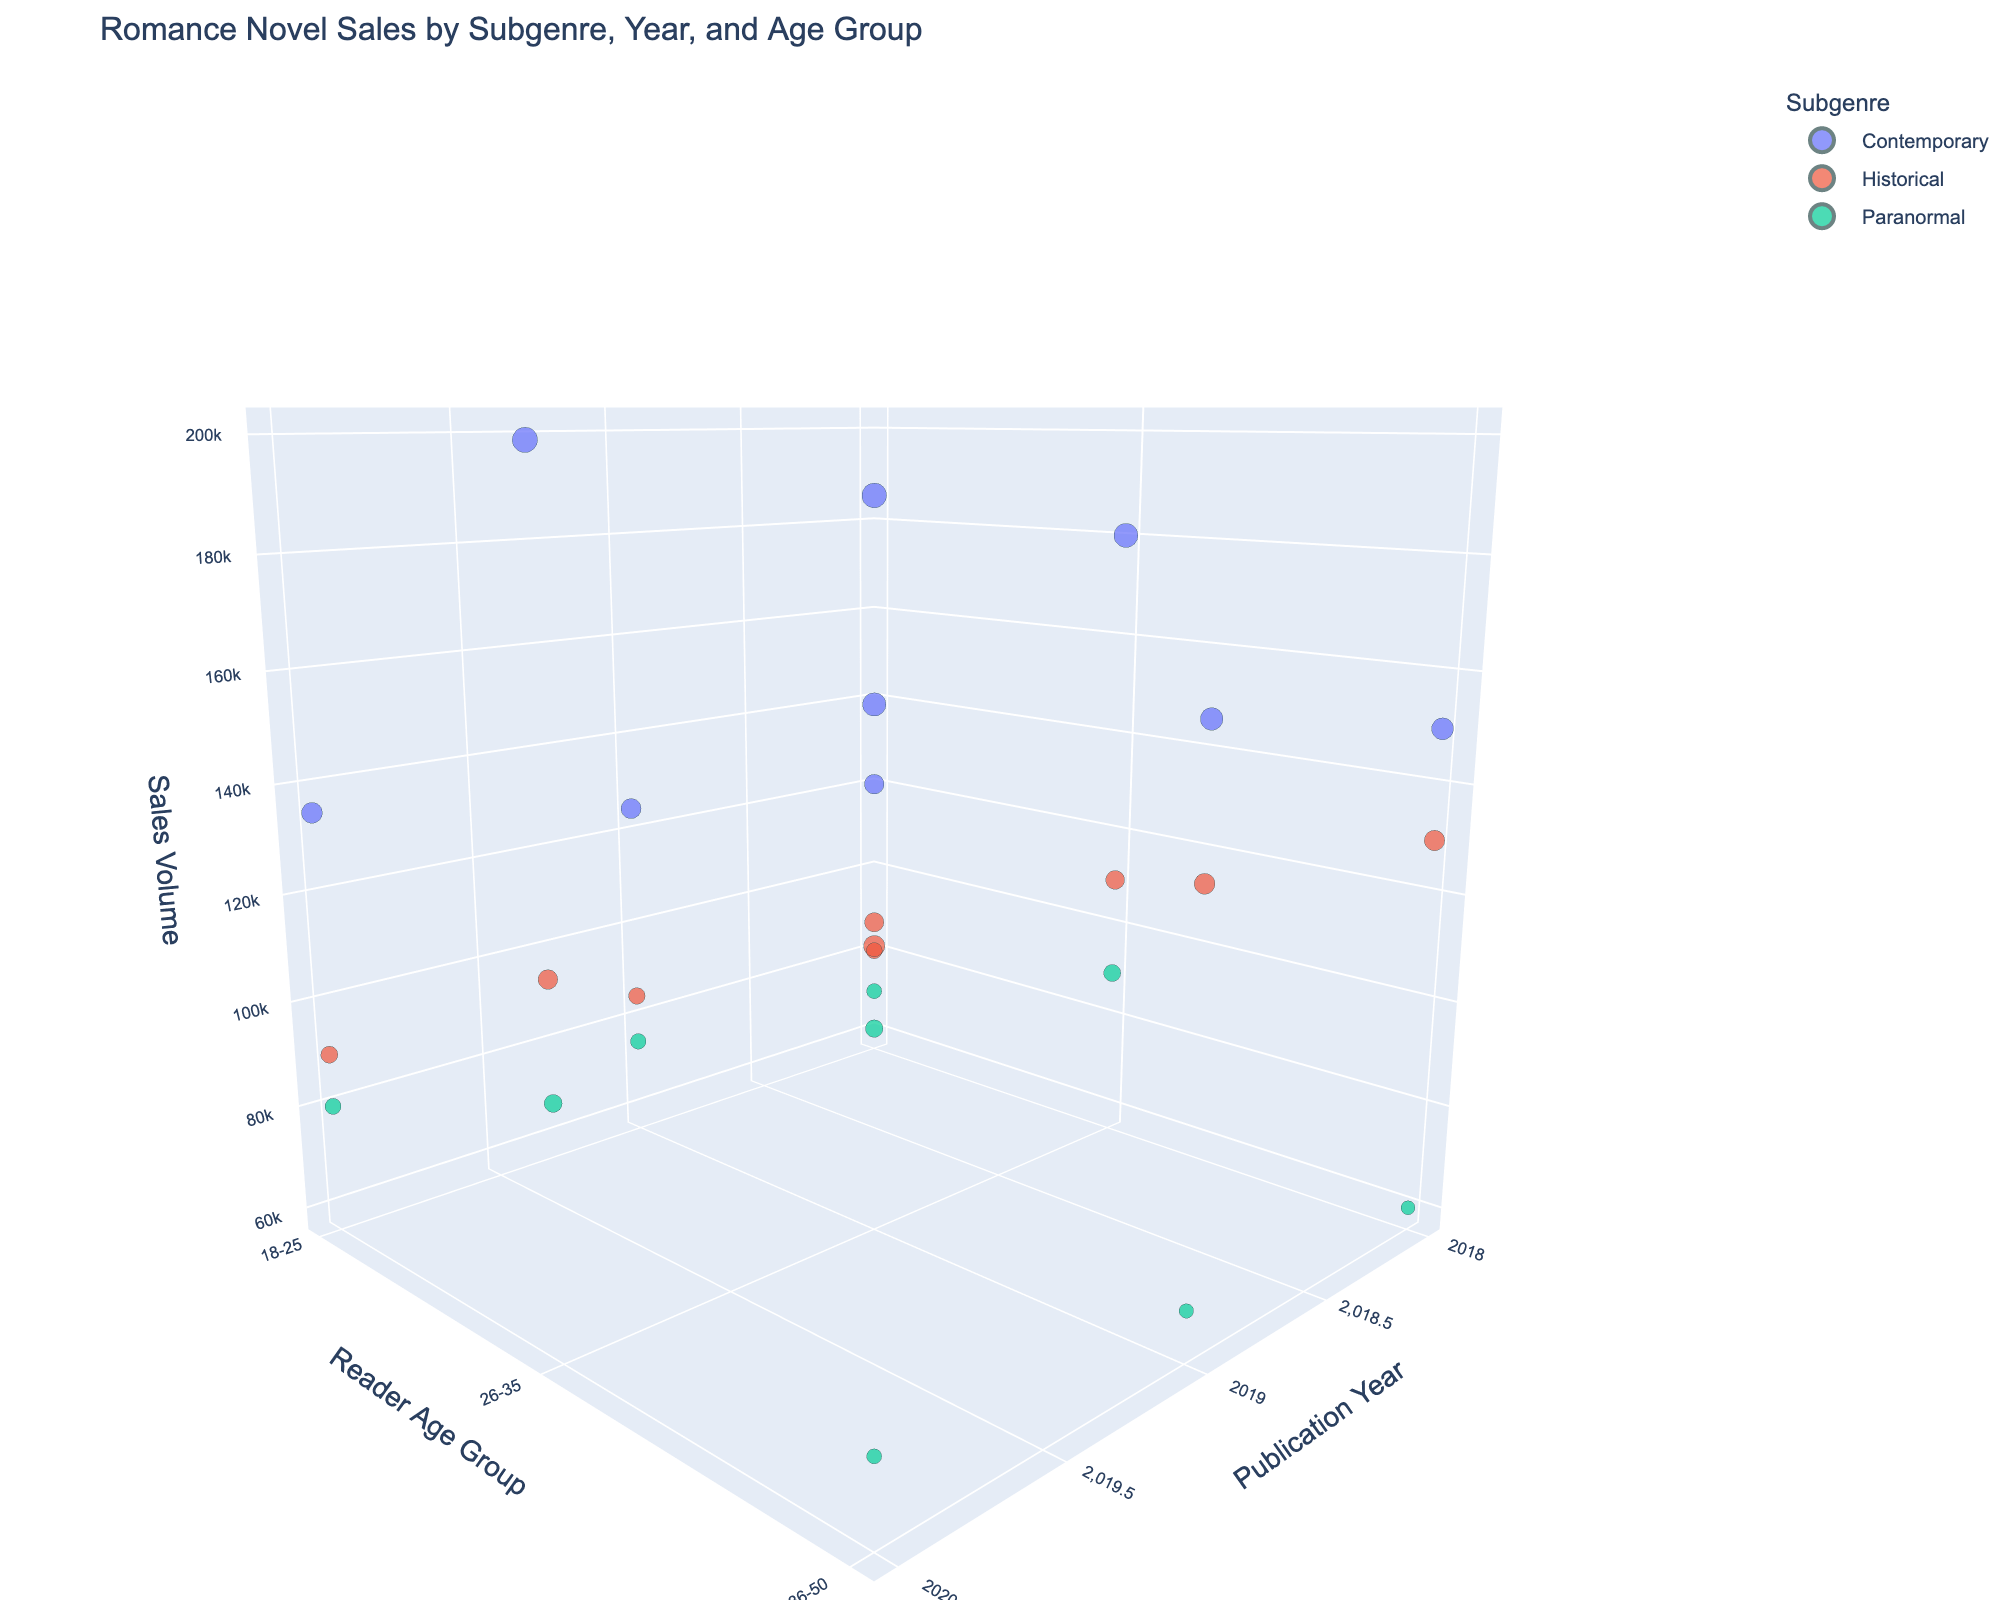What is the title of the figure? The title is often located at the top of the plot and provides an overall description. In this case, the title reads “Romance Novel Sales by Subgenre, Year, and Age Group”.
Answer: Romance Novel Sales by Subgenre, Year, and Age Group Which subgenre had the highest sales volume in 2020 for the age group 26-35? To find this, look at the data points corresponding to the year 2020 and age group 26-35, and identify which subgenre has the largest marker size. The largest marker size represents the highest sales volume.
Answer: Contemporary What is the sales volume for Historical subgenre in 2019 for the age group 36-50? Navigate to the data point where the subgenre is Historical, the publication year is 2019, and the reader age group is 36-50. The sales volume value next to this data point on the plot is 135,000.
Answer: 135,000 Compare the sales volume of Paranormal and Contemporary subgenres in 2018 for the age group 18-25. Which is higher? Find the markers for Paranormal and Contemporary subgenres with publication year 2018 and age group 18-25. Compare the sizes of these markers to determine the larger one. Contemporary has a sales volume of 120,000 compared to Paranormal's 70,000.
Answer: Contemporary What is the trend of sales volume for Contemporary subgenre from 2018 to 2020 for the age group 36-50? Identify the markers for Contemporary subgenre, age group 36-50, and follow their position along the z-axis (Sales Volume) from 2018 to 2020. The volumes increase from 150,000 to 160,000 to 170,000.
Answer: Increasing Which reader age group had the lowest sales volume for Historical subgenre in 2018? Locate the markers for the Historical subgenre in 2018, and compare the sales volumes across all age groups. The 18-25 group has the lowest sales volume at 80,000.
Answer: 18-25 On average, which subgenre had the highest sales volume in 2019? Calculate the average sales for each subgenre in 2019 by summing up their sales volumes and dividing by the number of data points (3). Contemporary: (125,000 + 190,000 + 160,000)/3, Historical: (85,000 + 115,000 + 135,000)/3, Paranormal: (75,000 + 95,000 + 65,000)/3. Contemporary has the highest average.
Answer: Contemporary Is the sales volume for Paranormal subgenre increasing or decreasing from 2018 to 2020 for all age groups? Check the trend of sales volumes for Paranormal subgenre markers for the years 2018 to 2020 across all age groups (18-25, 26-35, 36-50). The overall trend is increasing, as the sales volumes go up for each age group over the years.
Answer: Increasing Among the three years, which year had the lowest overall sales volume for the Historical subgenre in the 26-35 age group? Compare the sales volumes for the Historical subgenre markers for the 26-35 age group in 2018, 2019, and 2020. The values are 110,000, 115,000, and 120,000 respectively, making 2018 the lowest.
Answer: 2018 